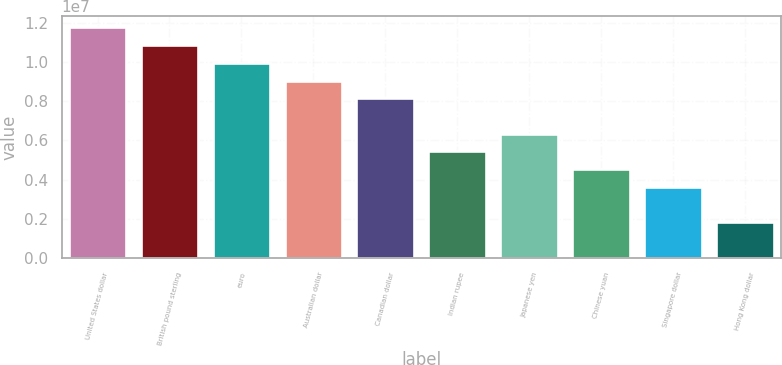Convert chart to OTSL. <chart><loc_0><loc_0><loc_500><loc_500><bar_chart><fcel>United States dollar<fcel>British pound sterling<fcel>euro<fcel>Australian dollar<fcel>Canadian dollar<fcel>Indian rupee<fcel>Japanese yen<fcel>Chinese yuan<fcel>Singapore dollar<fcel>Hong Kong dollar<nl><fcel>1.17581e+07<fcel>1.08554e+07<fcel>9.95266e+06<fcel>9.04992e+06<fcel>8.14718e+06<fcel>5.43895e+06<fcel>6.34169e+06<fcel>4.53621e+06<fcel>3.63346e+06<fcel>1.82798e+06<nl></chart> 